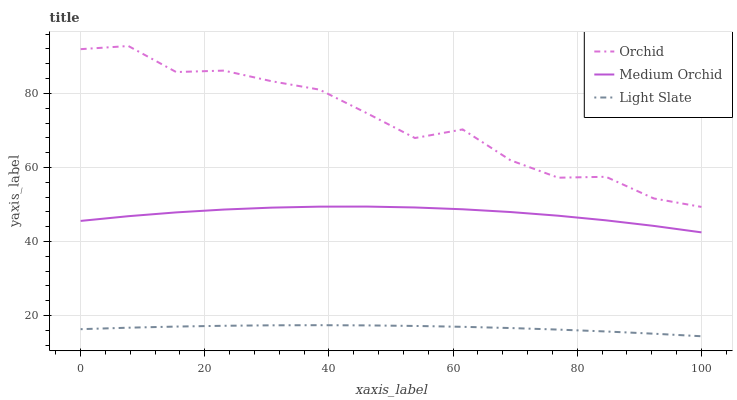Does Light Slate have the minimum area under the curve?
Answer yes or no. Yes. Does Orchid have the maximum area under the curve?
Answer yes or no. Yes. Does Medium Orchid have the minimum area under the curve?
Answer yes or no. No. Does Medium Orchid have the maximum area under the curve?
Answer yes or no. No. Is Light Slate the smoothest?
Answer yes or no. Yes. Is Orchid the roughest?
Answer yes or no. Yes. Is Medium Orchid the smoothest?
Answer yes or no. No. Is Medium Orchid the roughest?
Answer yes or no. No. Does Light Slate have the lowest value?
Answer yes or no. Yes. Does Medium Orchid have the lowest value?
Answer yes or no. No. Does Orchid have the highest value?
Answer yes or no. Yes. Does Medium Orchid have the highest value?
Answer yes or no. No. Is Medium Orchid less than Orchid?
Answer yes or no. Yes. Is Orchid greater than Light Slate?
Answer yes or no. Yes. Does Medium Orchid intersect Orchid?
Answer yes or no. No. 